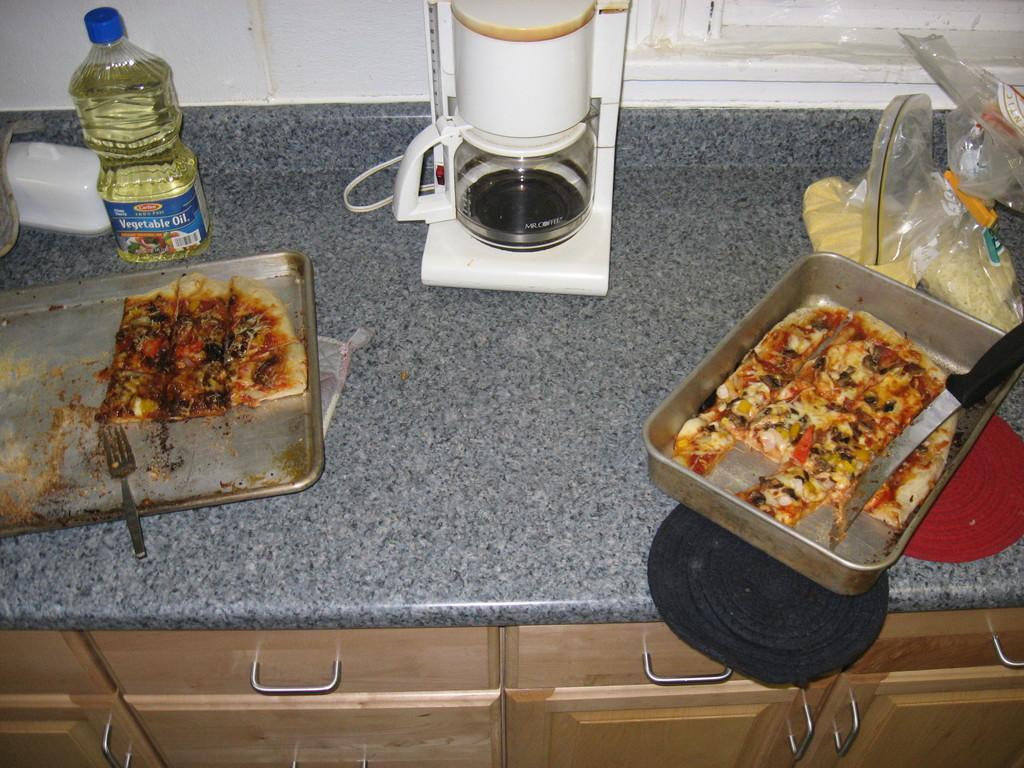What is present on the table in the image? There are eatables, a mixer, and oil on the table. What might be used for blending or mixing in the image? The mixer on the table might be used for blending or mixing. What type of liquid is visible on the table? Oil is visible on the table. How many baskets are present on the table in the image? There are no baskets present on the table in the image. What type of lip can be seen on the table in the image? There is no lip present on the table in the image. 